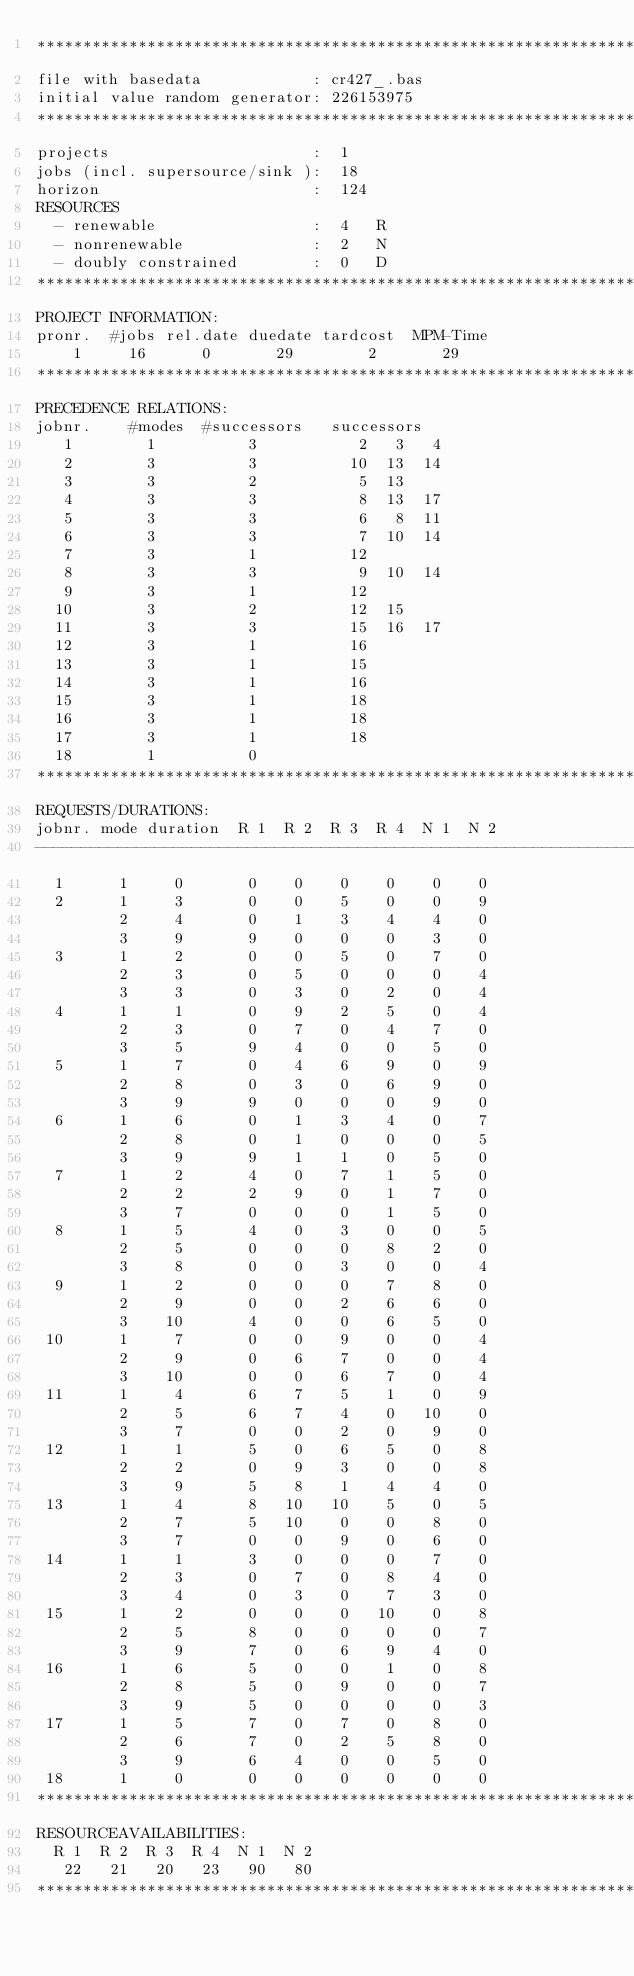<code> <loc_0><loc_0><loc_500><loc_500><_ObjectiveC_>************************************************************************
file with basedata            : cr427_.bas
initial value random generator: 226153975
************************************************************************
projects                      :  1
jobs (incl. supersource/sink ):  18
horizon                       :  124
RESOURCES
  - renewable                 :  4   R
  - nonrenewable              :  2   N
  - doubly constrained        :  0   D
************************************************************************
PROJECT INFORMATION:
pronr.  #jobs rel.date duedate tardcost  MPM-Time
    1     16      0       29        2       29
************************************************************************
PRECEDENCE RELATIONS:
jobnr.    #modes  #successors   successors
   1        1          3           2   3   4
   2        3          3          10  13  14
   3        3          2           5  13
   4        3          3           8  13  17
   5        3          3           6   8  11
   6        3          3           7  10  14
   7        3          1          12
   8        3          3           9  10  14
   9        3          1          12
  10        3          2          12  15
  11        3          3          15  16  17
  12        3          1          16
  13        3          1          15
  14        3          1          16
  15        3          1          18
  16        3          1          18
  17        3          1          18
  18        1          0        
************************************************************************
REQUESTS/DURATIONS:
jobnr. mode duration  R 1  R 2  R 3  R 4  N 1  N 2
------------------------------------------------------------------------
  1      1     0       0    0    0    0    0    0
  2      1     3       0    0    5    0    0    9
         2     4       0    1    3    4    4    0
         3     9       9    0    0    0    3    0
  3      1     2       0    0    5    0    7    0
         2     3       0    5    0    0    0    4
         3     3       0    3    0    2    0    4
  4      1     1       0    9    2    5    0    4
         2     3       0    7    0    4    7    0
         3     5       9    4    0    0    5    0
  5      1     7       0    4    6    9    0    9
         2     8       0    3    0    6    9    0
         3     9       9    0    0    0    9    0
  6      1     6       0    1    3    4    0    7
         2     8       0    1    0    0    0    5
         3     9       9    1    1    0    5    0
  7      1     2       4    0    7    1    5    0
         2     2       2    9    0    1    7    0
         3     7       0    0    0    1    5    0
  8      1     5       4    0    3    0    0    5
         2     5       0    0    0    8    2    0
         3     8       0    0    3    0    0    4
  9      1     2       0    0    0    7    8    0
         2     9       0    0    2    6    6    0
         3    10       4    0    0    6    5    0
 10      1     7       0    0    9    0    0    4
         2     9       0    6    7    0    0    4
         3    10       0    0    6    7    0    4
 11      1     4       6    7    5    1    0    9
         2     5       6    7    4    0   10    0
         3     7       0    0    2    0    9    0
 12      1     1       5    0    6    5    0    8
         2     2       0    9    3    0    0    8
         3     9       5    8    1    4    4    0
 13      1     4       8   10   10    5    0    5
         2     7       5   10    0    0    8    0
         3     7       0    0    9    0    6    0
 14      1     1       3    0    0    0    7    0
         2     3       0    7    0    8    4    0
         3     4       0    3    0    7    3    0
 15      1     2       0    0    0   10    0    8
         2     5       8    0    0    0    0    7
         3     9       7    0    6    9    4    0
 16      1     6       5    0    0    1    0    8
         2     8       5    0    9    0    0    7
         3     9       5    0    0    0    0    3
 17      1     5       7    0    7    0    8    0
         2     6       7    0    2    5    8    0
         3     9       6    4    0    0    5    0
 18      1     0       0    0    0    0    0    0
************************************************************************
RESOURCEAVAILABILITIES:
  R 1  R 2  R 3  R 4  N 1  N 2
   22   21   20   23   90   80
************************************************************************
</code> 